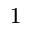Convert formula to latex. <formula><loc_0><loc_0><loc_500><loc_500>^ { 1 }</formula> 